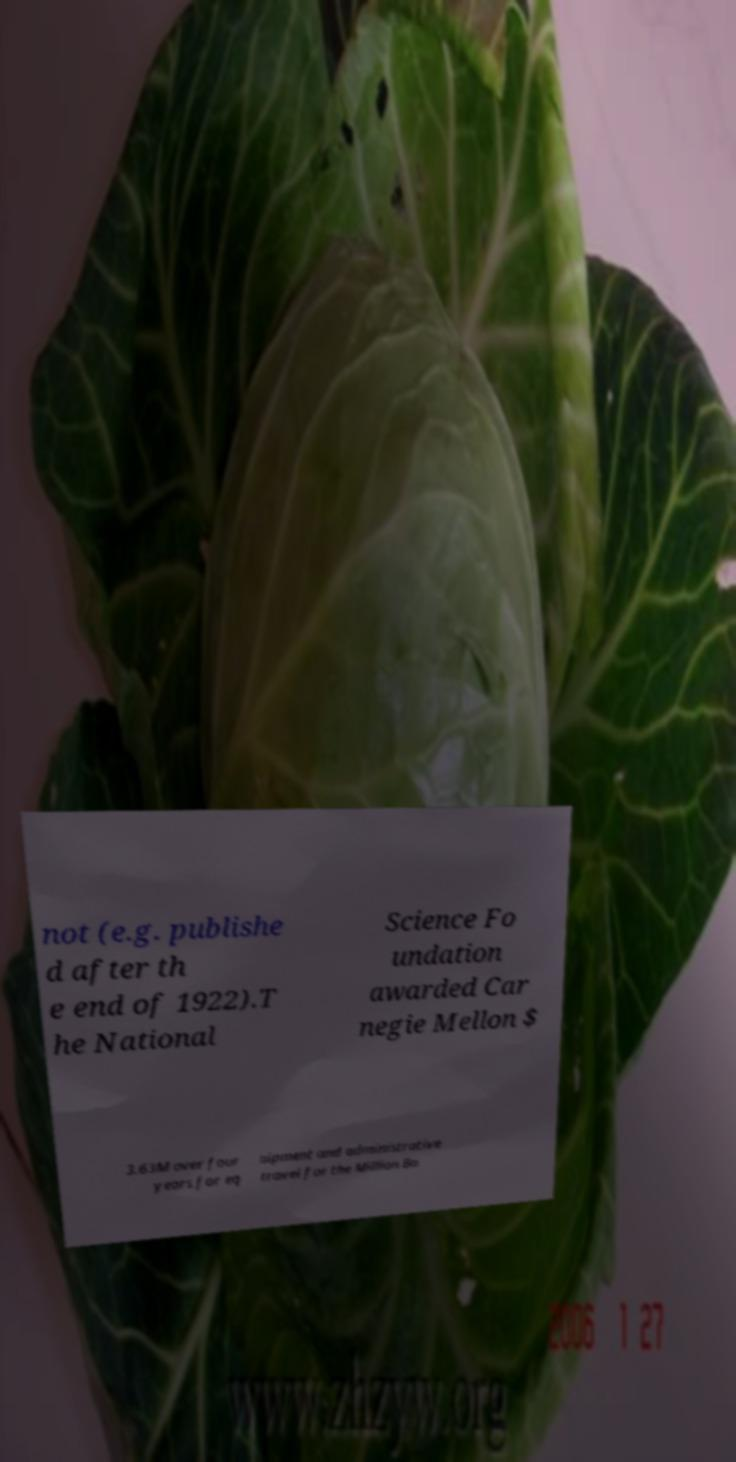Can you accurately transcribe the text from the provided image for me? not (e.g. publishe d after th e end of 1922).T he National Science Fo undation awarded Car negie Mellon $ 3.63M over four years for eq uipment and administrative travel for the Million Bo 